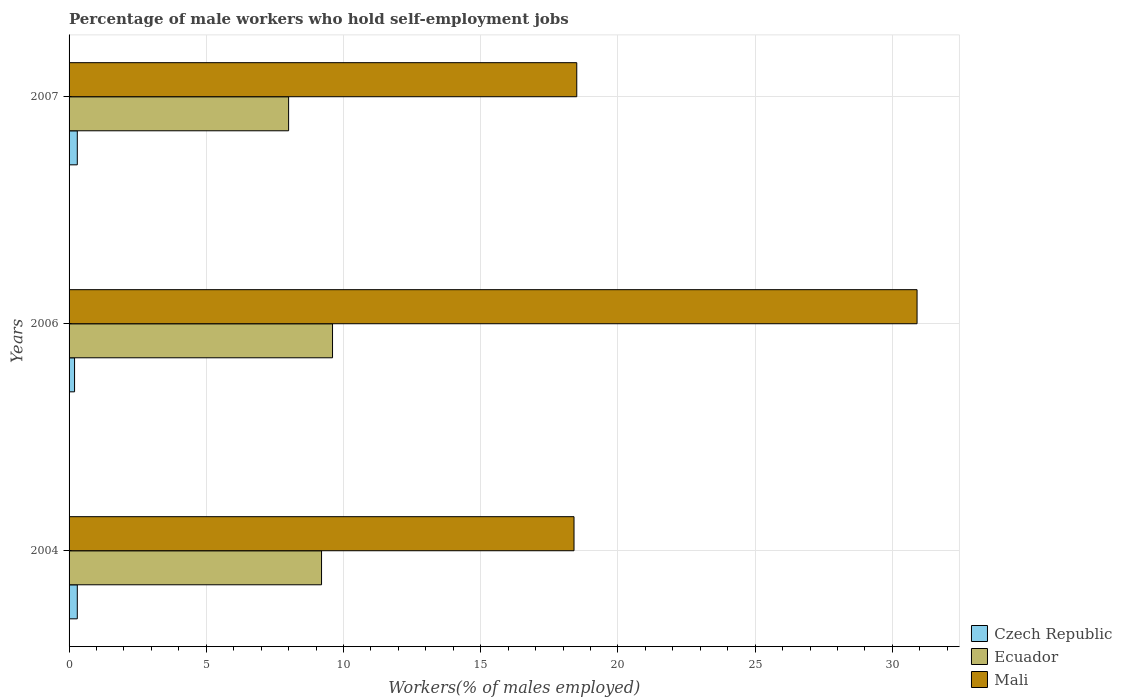How many different coloured bars are there?
Ensure brevity in your answer.  3. How many bars are there on the 2nd tick from the top?
Provide a short and direct response. 3. What is the label of the 3rd group of bars from the top?
Give a very brief answer. 2004. What is the percentage of self-employed male workers in Mali in 2004?
Your response must be concise. 18.4. Across all years, what is the maximum percentage of self-employed male workers in Ecuador?
Your answer should be compact. 9.6. Across all years, what is the minimum percentage of self-employed male workers in Czech Republic?
Your answer should be very brief. 0.2. In which year was the percentage of self-employed male workers in Mali maximum?
Your answer should be very brief. 2006. What is the total percentage of self-employed male workers in Mali in the graph?
Make the answer very short. 67.8. What is the difference between the percentage of self-employed male workers in Mali in 2006 and that in 2007?
Make the answer very short. 12.4. What is the difference between the percentage of self-employed male workers in Ecuador in 2004 and the percentage of self-employed male workers in Czech Republic in 2007?
Your response must be concise. 8.9. What is the average percentage of self-employed male workers in Czech Republic per year?
Keep it short and to the point. 0.27. In the year 2004, what is the difference between the percentage of self-employed male workers in Mali and percentage of self-employed male workers in Ecuador?
Your answer should be compact. 9.2. What is the ratio of the percentage of self-employed male workers in Czech Republic in 2006 to that in 2007?
Provide a succinct answer. 0.67. What is the difference between the highest and the second highest percentage of self-employed male workers in Czech Republic?
Provide a succinct answer. 0. What is the difference between the highest and the lowest percentage of self-employed male workers in Ecuador?
Offer a very short reply. 1.6. What does the 3rd bar from the top in 2004 represents?
Your answer should be very brief. Czech Republic. What does the 1st bar from the bottom in 2004 represents?
Ensure brevity in your answer.  Czech Republic. Is it the case that in every year, the sum of the percentage of self-employed male workers in Mali and percentage of self-employed male workers in Czech Republic is greater than the percentage of self-employed male workers in Ecuador?
Provide a short and direct response. Yes. How many bars are there?
Provide a short and direct response. 9. Are all the bars in the graph horizontal?
Provide a succinct answer. Yes. How many years are there in the graph?
Your answer should be compact. 3. Where does the legend appear in the graph?
Your response must be concise. Bottom right. How many legend labels are there?
Your answer should be very brief. 3. How are the legend labels stacked?
Ensure brevity in your answer.  Vertical. What is the title of the graph?
Offer a terse response. Percentage of male workers who hold self-employment jobs. Does "Bermuda" appear as one of the legend labels in the graph?
Make the answer very short. No. What is the label or title of the X-axis?
Offer a terse response. Workers(% of males employed). What is the label or title of the Y-axis?
Keep it short and to the point. Years. What is the Workers(% of males employed) in Czech Republic in 2004?
Ensure brevity in your answer.  0.3. What is the Workers(% of males employed) of Ecuador in 2004?
Your answer should be compact. 9.2. What is the Workers(% of males employed) in Mali in 2004?
Ensure brevity in your answer.  18.4. What is the Workers(% of males employed) in Czech Republic in 2006?
Offer a very short reply. 0.2. What is the Workers(% of males employed) of Ecuador in 2006?
Provide a succinct answer. 9.6. What is the Workers(% of males employed) in Mali in 2006?
Ensure brevity in your answer.  30.9. What is the Workers(% of males employed) in Czech Republic in 2007?
Your answer should be very brief. 0.3. Across all years, what is the maximum Workers(% of males employed) of Czech Republic?
Give a very brief answer. 0.3. Across all years, what is the maximum Workers(% of males employed) in Ecuador?
Make the answer very short. 9.6. Across all years, what is the maximum Workers(% of males employed) in Mali?
Make the answer very short. 30.9. Across all years, what is the minimum Workers(% of males employed) in Czech Republic?
Your response must be concise. 0.2. Across all years, what is the minimum Workers(% of males employed) in Ecuador?
Offer a terse response. 8. Across all years, what is the minimum Workers(% of males employed) in Mali?
Offer a very short reply. 18.4. What is the total Workers(% of males employed) of Ecuador in the graph?
Make the answer very short. 26.8. What is the total Workers(% of males employed) of Mali in the graph?
Provide a short and direct response. 67.8. What is the difference between the Workers(% of males employed) in Czech Republic in 2004 and that in 2006?
Offer a terse response. 0.1. What is the difference between the Workers(% of males employed) in Mali in 2004 and that in 2006?
Your response must be concise. -12.5. What is the difference between the Workers(% of males employed) of Czech Republic in 2004 and that in 2007?
Keep it short and to the point. 0. What is the difference between the Workers(% of males employed) of Ecuador in 2004 and that in 2007?
Your answer should be compact. 1.2. What is the difference between the Workers(% of males employed) of Mali in 2004 and that in 2007?
Your response must be concise. -0.1. What is the difference between the Workers(% of males employed) of Czech Republic in 2006 and that in 2007?
Provide a succinct answer. -0.1. What is the difference between the Workers(% of males employed) of Mali in 2006 and that in 2007?
Give a very brief answer. 12.4. What is the difference between the Workers(% of males employed) in Czech Republic in 2004 and the Workers(% of males employed) in Ecuador in 2006?
Keep it short and to the point. -9.3. What is the difference between the Workers(% of males employed) in Czech Republic in 2004 and the Workers(% of males employed) in Mali in 2006?
Provide a short and direct response. -30.6. What is the difference between the Workers(% of males employed) of Ecuador in 2004 and the Workers(% of males employed) of Mali in 2006?
Your answer should be very brief. -21.7. What is the difference between the Workers(% of males employed) of Czech Republic in 2004 and the Workers(% of males employed) of Mali in 2007?
Your answer should be very brief. -18.2. What is the difference between the Workers(% of males employed) of Czech Republic in 2006 and the Workers(% of males employed) of Ecuador in 2007?
Give a very brief answer. -7.8. What is the difference between the Workers(% of males employed) in Czech Republic in 2006 and the Workers(% of males employed) in Mali in 2007?
Offer a terse response. -18.3. What is the average Workers(% of males employed) in Czech Republic per year?
Your answer should be compact. 0.27. What is the average Workers(% of males employed) of Ecuador per year?
Provide a short and direct response. 8.93. What is the average Workers(% of males employed) of Mali per year?
Provide a short and direct response. 22.6. In the year 2004, what is the difference between the Workers(% of males employed) in Czech Republic and Workers(% of males employed) in Ecuador?
Offer a very short reply. -8.9. In the year 2004, what is the difference between the Workers(% of males employed) in Czech Republic and Workers(% of males employed) in Mali?
Offer a very short reply. -18.1. In the year 2006, what is the difference between the Workers(% of males employed) of Czech Republic and Workers(% of males employed) of Mali?
Offer a terse response. -30.7. In the year 2006, what is the difference between the Workers(% of males employed) in Ecuador and Workers(% of males employed) in Mali?
Provide a short and direct response. -21.3. In the year 2007, what is the difference between the Workers(% of males employed) in Czech Republic and Workers(% of males employed) in Mali?
Provide a succinct answer. -18.2. In the year 2007, what is the difference between the Workers(% of males employed) of Ecuador and Workers(% of males employed) of Mali?
Offer a terse response. -10.5. What is the ratio of the Workers(% of males employed) in Ecuador in 2004 to that in 2006?
Your answer should be compact. 0.96. What is the ratio of the Workers(% of males employed) in Mali in 2004 to that in 2006?
Offer a terse response. 0.6. What is the ratio of the Workers(% of males employed) of Ecuador in 2004 to that in 2007?
Your response must be concise. 1.15. What is the ratio of the Workers(% of males employed) of Mali in 2004 to that in 2007?
Provide a succinct answer. 0.99. What is the ratio of the Workers(% of males employed) in Mali in 2006 to that in 2007?
Make the answer very short. 1.67. What is the difference between the highest and the second highest Workers(% of males employed) of Czech Republic?
Offer a very short reply. 0. What is the difference between the highest and the second highest Workers(% of males employed) in Mali?
Your answer should be very brief. 12.4. What is the difference between the highest and the lowest Workers(% of males employed) in Czech Republic?
Ensure brevity in your answer.  0.1. What is the difference between the highest and the lowest Workers(% of males employed) of Ecuador?
Keep it short and to the point. 1.6. 